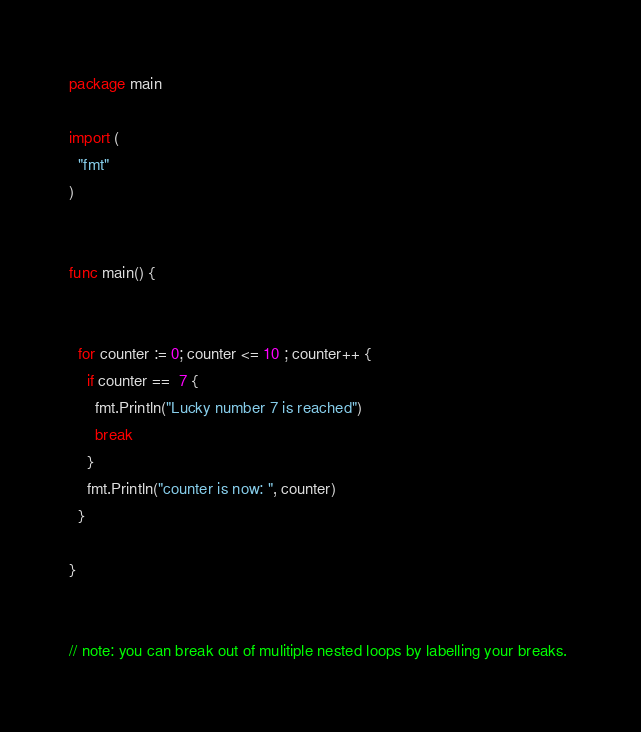<code> <loc_0><loc_0><loc_500><loc_500><_Go_>package main

import (
  "fmt"
)


func main() {


  for counter := 0; counter <= 10 ; counter++ {
    if counter ==  7 {
      fmt.Println("Lucky number 7 is reached")
      break
    }
    fmt.Println("counter is now: ", counter)
  }

}


// note: you can break out of mulitiple nested loops by labelling your breaks. 
</code> 